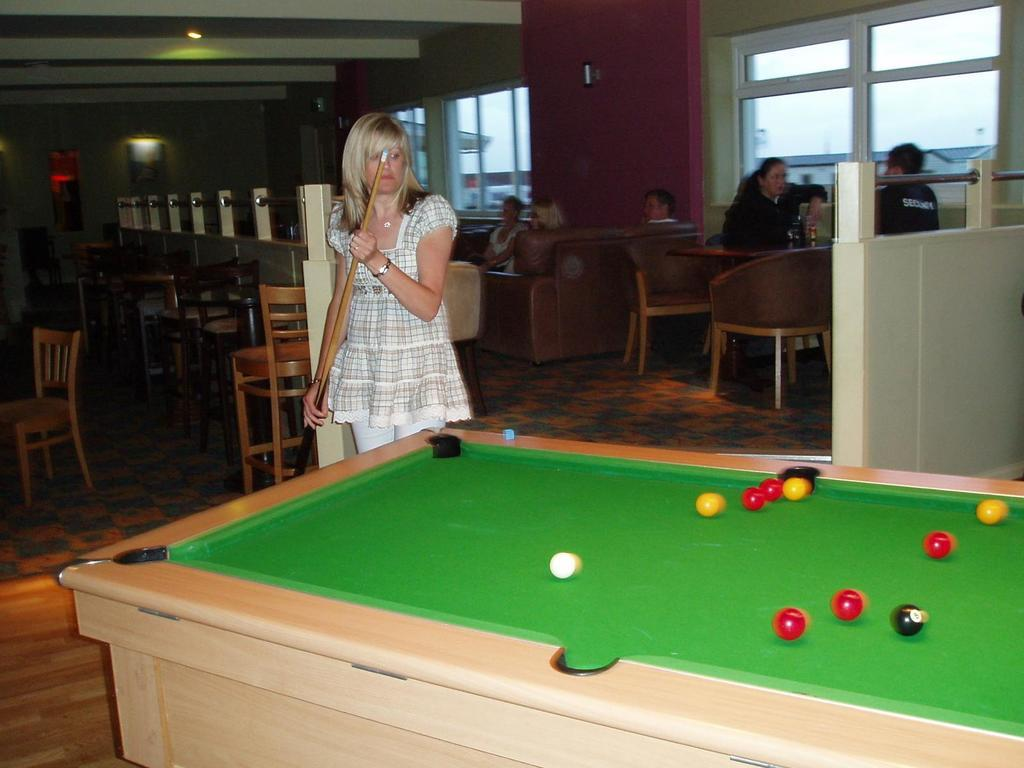What activity is the woman in the image engaged in? The woman is playing snooker in the image. Where are the other people in the image located? There is a man and a woman sitting on a table on the right side of the image, and there are three people sitting on a sofa in the image. What type of smile can be seen on the queen's face in the image? There is no queen present in the image, and therefore no smile to observe. 